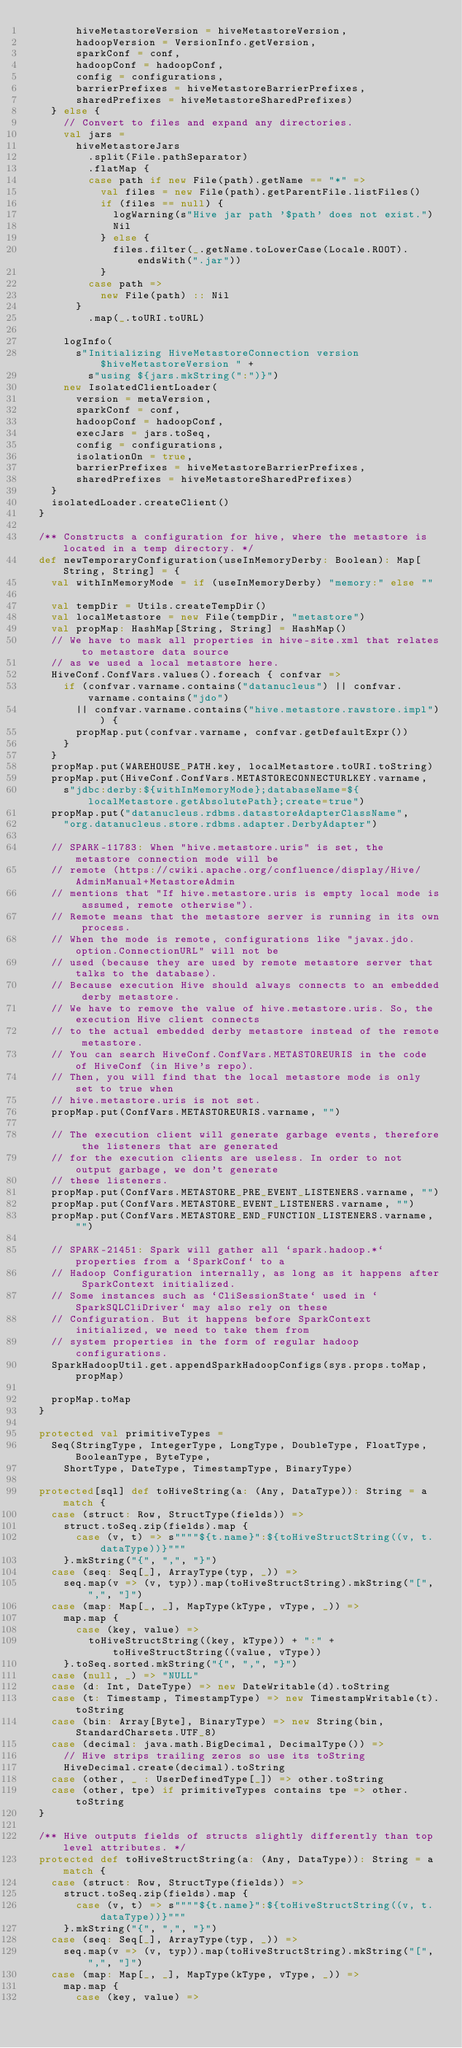<code> <loc_0><loc_0><loc_500><loc_500><_Scala_>        hiveMetastoreVersion = hiveMetastoreVersion,
        hadoopVersion = VersionInfo.getVersion,
        sparkConf = conf,
        hadoopConf = hadoopConf,
        config = configurations,
        barrierPrefixes = hiveMetastoreBarrierPrefixes,
        sharedPrefixes = hiveMetastoreSharedPrefixes)
    } else {
      // Convert to files and expand any directories.
      val jars =
        hiveMetastoreJars
          .split(File.pathSeparator)
          .flatMap {
          case path if new File(path).getName == "*" =>
            val files = new File(path).getParentFile.listFiles()
            if (files == null) {
              logWarning(s"Hive jar path '$path' does not exist.")
              Nil
            } else {
              files.filter(_.getName.toLowerCase(Locale.ROOT).endsWith(".jar"))
            }
          case path =>
            new File(path) :: Nil
        }
          .map(_.toURI.toURL)

      logInfo(
        s"Initializing HiveMetastoreConnection version $hiveMetastoreVersion " +
          s"using ${jars.mkString(":")}")
      new IsolatedClientLoader(
        version = metaVersion,
        sparkConf = conf,
        hadoopConf = hadoopConf,
        execJars = jars.toSeq,
        config = configurations,
        isolationOn = true,
        barrierPrefixes = hiveMetastoreBarrierPrefixes,
        sharedPrefixes = hiveMetastoreSharedPrefixes)
    }
    isolatedLoader.createClient()
  }

  /** Constructs a configuration for hive, where the metastore is located in a temp directory. */
  def newTemporaryConfiguration(useInMemoryDerby: Boolean): Map[String, String] = {
    val withInMemoryMode = if (useInMemoryDerby) "memory:" else ""

    val tempDir = Utils.createTempDir()
    val localMetastore = new File(tempDir, "metastore")
    val propMap: HashMap[String, String] = HashMap()
    // We have to mask all properties in hive-site.xml that relates to metastore data source
    // as we used a local metastore here.
    HiveConf.ConfVars.values().foreach { confvar =>
      if (confvar.varname.contains("datanucleus") || confvar.varname.contains("jdo")
        || confvar.varname.contains("hive.metastore.rawstore.impl")) {
        propMap.put(confvar.varname, confvar.getDefaultExpr())
      }
    }
    propMap.put(WAREHOUSE_PATH.key, localMetastore.toURI.toString)
    propMap.put(HiveConf.ConfVars.METASTORECONNECTURLKEY.varname,
      s"jdbc:derby:${withInMemoryMode};databaseName=${localMetastore.getAbsolutePath};create=true")
    propMap.put("datanucleus.rdbms.datastoreAdapterClassName",
      "org.datanucleus.store.rdbms.adapter.DerbyAdapter")

    // SPARK-11783: When "hive.metastore.uris" is set, the metastore connection mode will be
    // remote (https://cwiki.apache.org/confluence/display/Hive/AdminManual+MetastoreAdmin
    // mentions that "If hive.metastore.uris is empty local mode is assumed, remote otherwise").
    // Remote means that the metastore server is running in its own process.
    // When the mode is remote, configurations like "javax.jdo.option.ConnectionURL" will not be
    // used (because they are used by remote metastore server that talks to the database).
    // Because execution Hive should always connects to an embedded derby metastore.
    // We have to remove the value of hive.metastore.uris. So, the execution Hive client connects
    // to the actual embedded derby metastore instead of the remote metastore.
    // You can search HiveConf.ConfVars.METASTOREURIS in the code of HiveConf (in Hive's repo).
    // Then, you will find that the local metastore mode is only set to true when
    // hive.metastore.uris is not set.
    propMap.put(ConfVars.METASTOREURIS.varname, "")

    // The execution client will generate garbage events, therefore the listeners that are generated
    // for the execution clients are useless. In order to not output garbage, we don't generate
    // these listeners.
    propMap.put(ConfVars.METASTORE_PRE_EVENT_LISTENERS.varname, "")
    propMap.put(ConfVars.METASTORE_EVENT_LISTENERS.varname, "")
    propMap.put(ConfVars.METASTORE_END_FUNCTION_LISTENERS.varname, "")

    // SPARK-21451: Spark will gather all `spark.hadoop.*` properties from a `SparkConf` to a
    // Hadoop Configuration internally, as long as it happens after SparkContext initialized.
    // Some instances such as `CliSessionState` used in `SparkSQLCliDriver` may also rely on these
    // Configuration. But it happens before SparkContext initialized, we need to take them from
    // system properties in the form of regular hadoop configurations.
    SparkHadoopUtil.get.appendSparkHadoopConfigs(sys.props.toMap, propMap)

    propMap.toMap
  }

  protected val primitiveTypes =
    Seq(StringType, IntegerType, LongType, DoubleType, FloatType, BooleanType, ByteType,
      ShortType, DateType, TimestampType, BinaryType)

  protected[sql] def toHiveString(a: (Any, DataType)): String = a match {
    case (struct: Row, StructType(fields)) =>
      struct.toSeq.zip(fields).map {
        case (v, t) => s""""${t.name}":${toHiveStructString((v, t.dataType))}"""
      }.mkString("{", ",", "}")
    case (seq: Seq[_], ArrayType(typ, _)) =>
      seq.map(v => (v, typ)).map(toHiveStructString).mkString("[", ",", "]")
    case (map: Map[_, _], MapType(kType, vType, _)) =>
      map.map {
        case (key, value) =>
          toHiveStructString((key, kType)) + ":" + toHiveStructString((value, vType))
      }.toSeq.sorted.mkString("{", ",", "}")
    case (null, _) => "NULL"
    case (d: Int, DateType) => new DateWritable(d).toString
    case (t: Timestamp, TimestampType) => new TimestampWritable(t).toString
    case (bin: Array[Byte], BinaryType) => new String(bin, StandardCharsets.UTF_8)
    case (decimal: java.math.BigDecimal, DecimalType()) =>
      // Hive strips trailing zeros so use its toString
      HiveDecimal.create(decimal).toString
    case (other, _ : UserDefinedType[_]) => other.toString
    case (other, tpe) if primitiveTypes contains tpe => other.toString
  }

  /** Hive outputs fields of structs slightly differently than top level attributes. */
  protected def toHiveStructString(a: (Any, DataType)): String = a match {
    case (struct: Row, StructType(fields)) =>
      struct.toSeq.zip(fields).map {
        case (v, t) => s""""${t.name}":${toHiveStructString((v, t.dataType))}"""
      }.mkString("{", ",", "}")
    case (seq: Seq[_], ArrayType(typ, _)) =>
      seq.map(v => (v, typ)).map(toHiveStructString).mkString("[", ",", "]")
    case (map: Map[_, _], MapType(kType, vType, _)) =>
      map.map {
        case (key, value) =></code> 